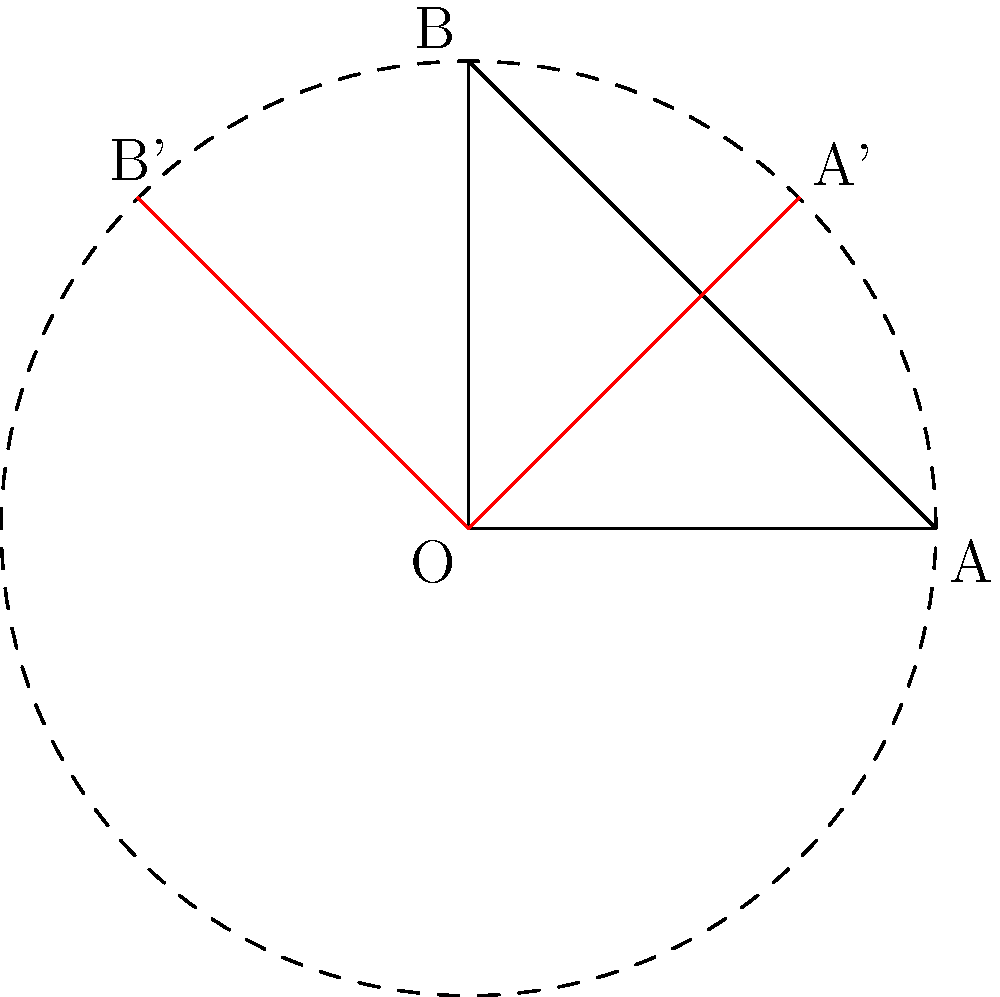You need to rotate your camera tripod setup by 45° clockwise around a fixed point. The initial position of two tripod legs is represented by points A(2,0) and B(0,2), with the fixed point at the origin O(0,0). What are the coordinates of points A and B after the rotation? To solve this problem, we need to apply the rotation formula for a point (x,y) around the origin by an angle θ:

$$(x', y') = (x \cos θ - y \sin θ, x \sin θ + y \cos θ)$$

Here, θ = 45° = π/4 radians, and we're rotating clockwise, so we'll use -θ in our calculations.

For point A(2,0):
1) $x' = 2 \cos(-π/4) - 0 \sin(-π/4) = 2 \cdot \frac{\sqrt{2}}{2} = \sqrt{2}$
2) $y' = 2 \sin(-π/4) + 0 \cos(-π/4) = -2 \cdot \frac{\sqrt{2}}{2} = -\sqrt{2}$

So, A' = $(\sqrt{2}, -\sqrt{2})$

For point B(0,2):
1) $x' = 0 \cos(-π/4) - 2 \sin(-π/4) = 2 \cdot \frac{\sqrt{2}}{2} = \sqrt{2}$
2) $y' = 0 \sin(-π/4) + 2 \cos(-π/4) = 2 \cdot \frac{\sqrt{2}}{2} = \sqrt{2}$

So, B' = $(\sqrt{2}, \sqrt{2})$
Answer: A': $(\sqrt{2}, -\sqrt{2})$, B': $(\sqrt{2}, \sqrt{2})$ 